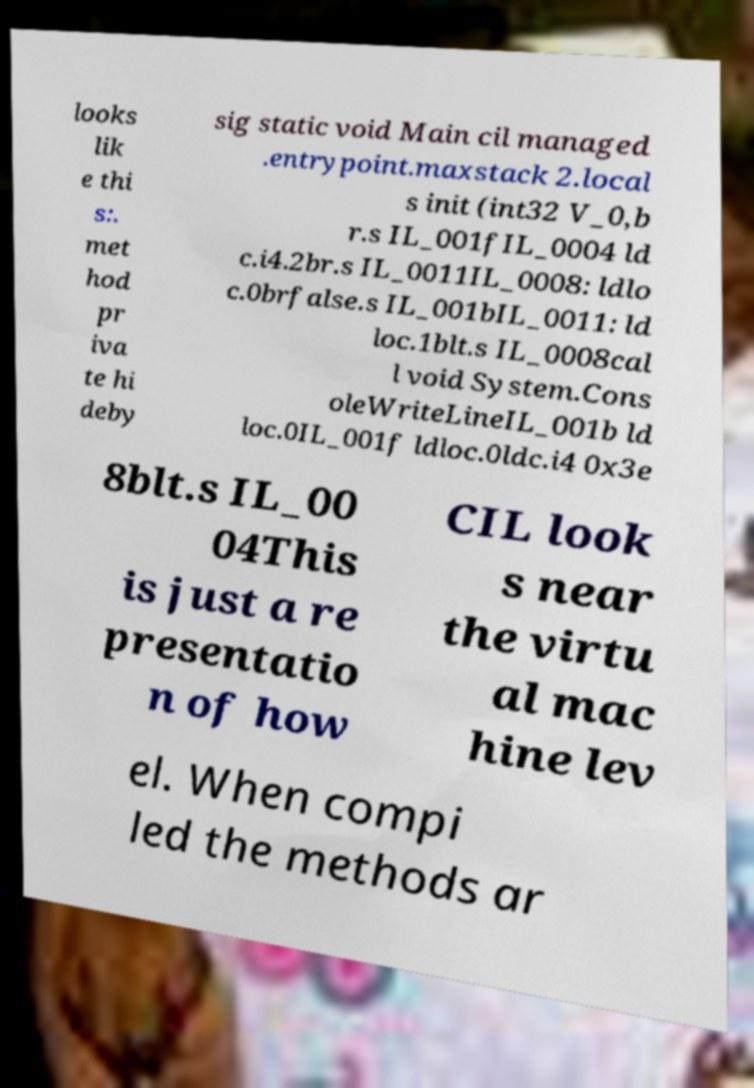There's text embedded in this image that I need extracted. Can you transcribe it verbatim? looks lik e thi s:. met hod pr iva te hi deby sig static void Main cil managed .entrypoint.maxstack 2.local s init (int32 V_0,b r.s IL_001fIL_0004 ld c.i4.2br.s IL_0011IL_0008: ldlo c.0brfalse.s IL_001bIL_0011: ld loc.1blt.s IL_0008cal l void System.Cons oleWriteLineIL_001b ld loc.0IL_001f ldloc.0ldc.i4 0x3e 8blt.s IL_00 04This is just a re presentatio n of how CIL look s near the virtu al mac hine lev el. When compi led the methods ar 